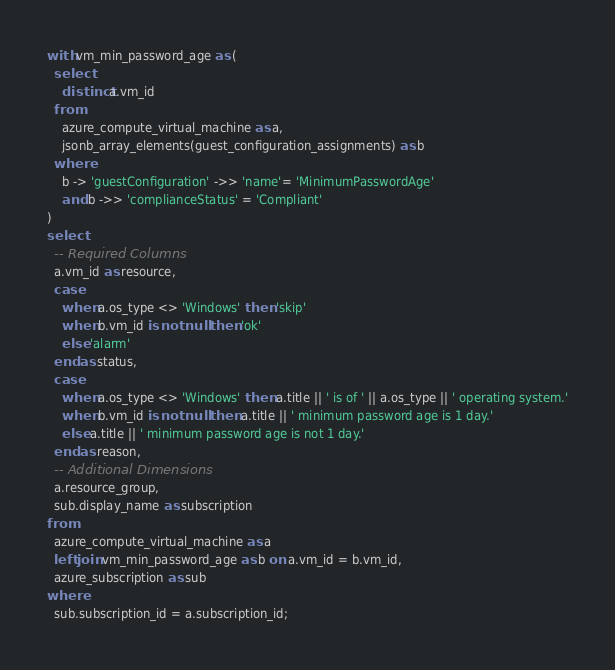<code> <loc_0><loc_0><loc_500><loc_500><_SQL_>with vm_min_password_age as (
  select
    distinct a.vm_id
  from
    azure_compute_virtual_machine as a,
    jsonb_array_elements(guest_configuration_assignments) as b
  where
    b -> 'guestConfiguration' ->> 'name'= 'MinimumPasswordAge'
    and b ->> 'complianceStatus' = 'Compliant'
)
select
  -- Required Columns
  a.vm_id as resource,
  case
    when a.os_type <> 'Windows' then 'skip'
    when b.vm_id is not null then 'ok'
    else 'alarm'
  end as status,
  case
    when a.os_type <> 'Windows' then a.title || ' is of ' || a.os_type || ' operating system.'
    when b.vm_id is not null then a.title || ' minimum password age is 1 day.'
    else a.title || ' minimum password age is not 1 day.'
  end as reason,
  -- Additional Dimensions
  a.resource_group,
  sub.display_name as subscription
from
  azure_compute_virtual_machine as a
  left join vm_min_password_age as b on a.vm_id = b.vm_id,
  azure_subscription as sub
where
  sub.subscription_id = a.subscription_id;</code> 